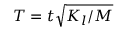Convert formula to latex. <formula><loc_0><loc_0><loc_500><loc_500>T = t \sqrt { K _ { l } / M }</formula> 